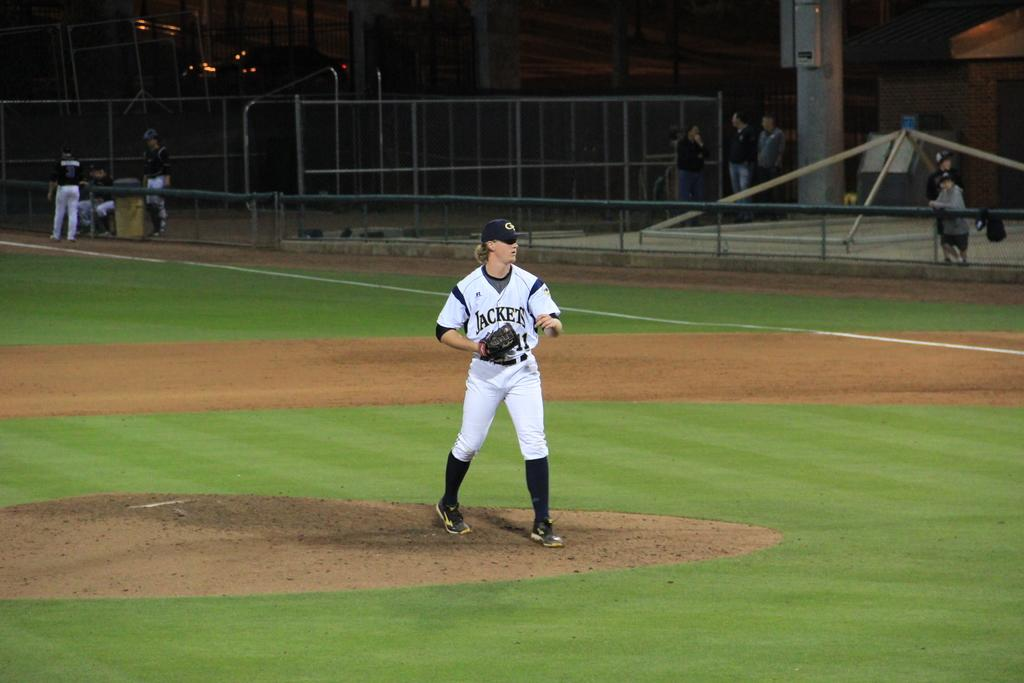<image>
Describe the image concisely. a baseball player in a Jackets jersey on the pitcher's mound looking to the right 